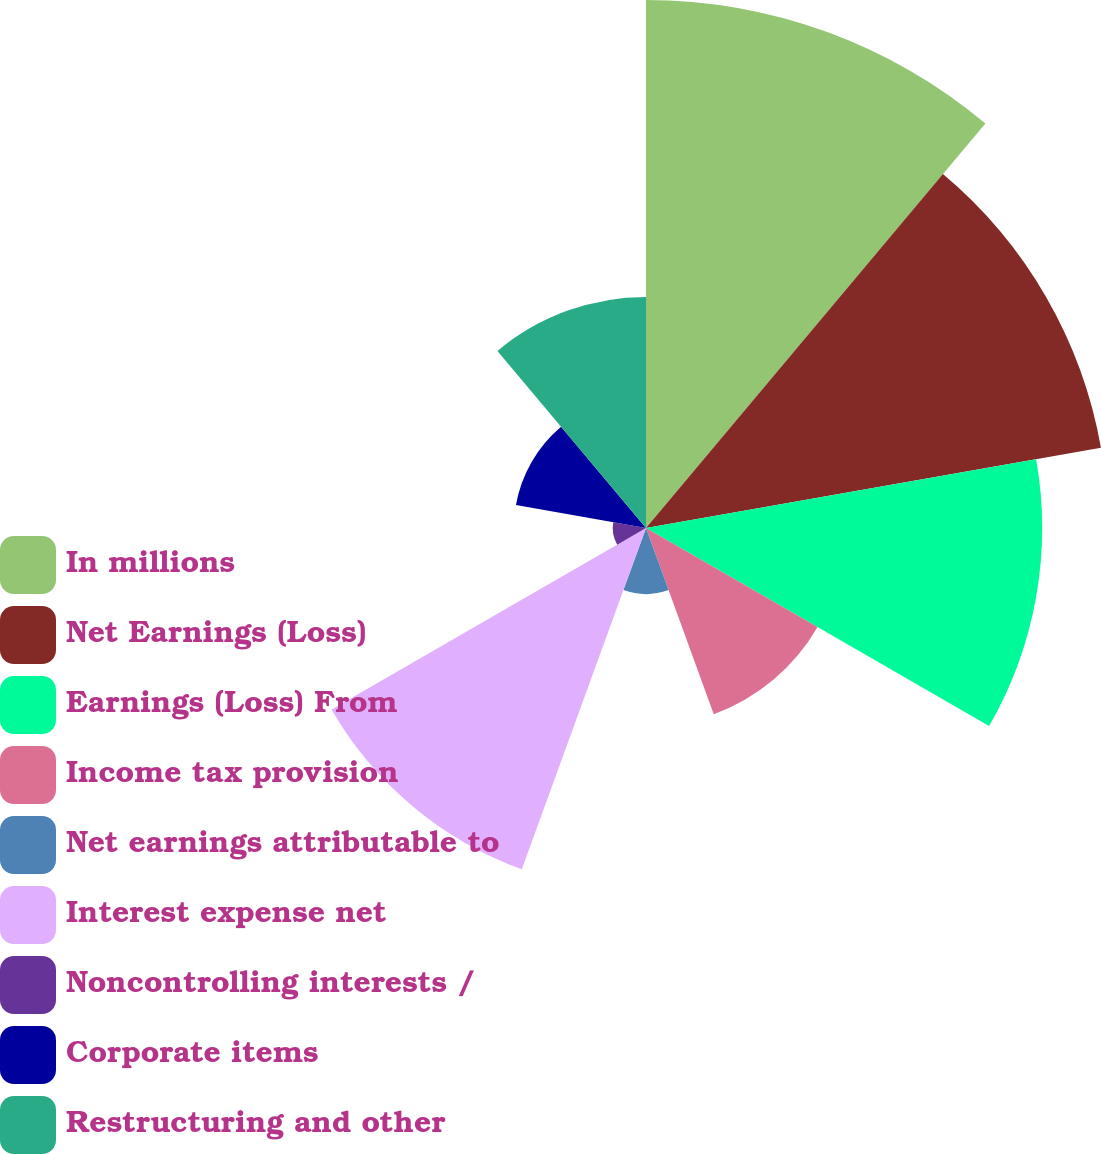Convert chart to OTSL. <chart><loc_0><loc_0><loc_500><loc_500><pie_chart><fcel>In millions<fcel>Net Earnings (Loss)<fcel>Earnings (Loss) From<fcel>Income tax provision<fcel>Net earnings attributable to<fcel>Interest expense net<fcel>Noncontrolling interests /<fcel>Corporate items<fcel>Restructuring and other<nl><fcel>21.91%<fcel>19.17%<fcel>16.44%<fcel>8.22%<fcel>2.74%<fcel>15.07%<fcel>1.38%<fcel>5.48%<fcel>9.59%<nl></chart> 